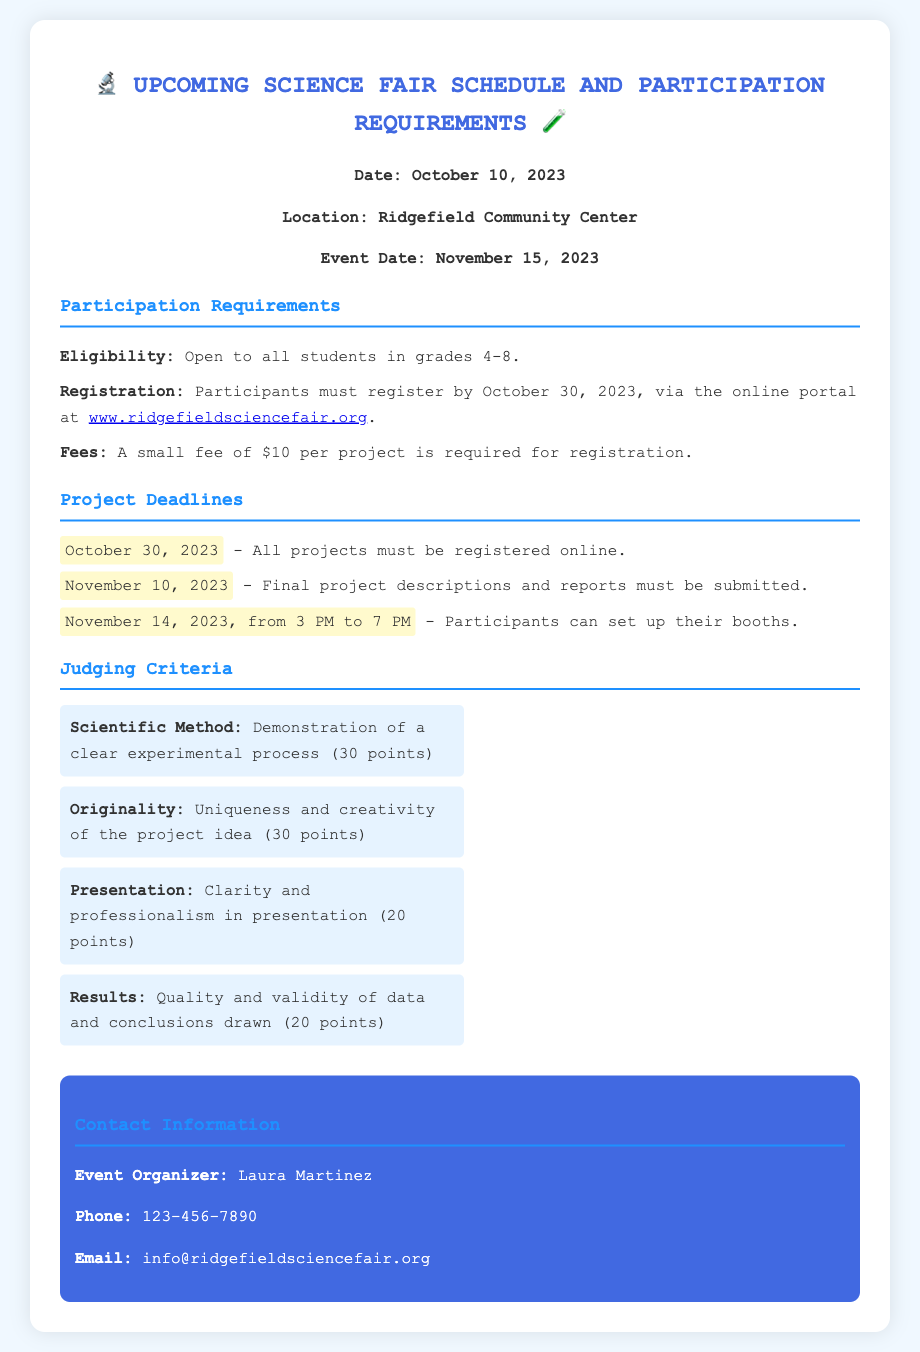What is the registration deadline? The registration deadline is specifically stated in the document as October 30, 2023.
Answer: October 30, 2023 Where is the event taking place? The location of the event is mentioned in the document as Ridgefield Community Center.
Answer: Ridgefield Community Center What is the fee for registration? The document clearly indicates that a small fee is required for registration, stating the amount as $10 per project.
Answer: $10 How many points are awarded for originality? The document specifies that originality is awarded 30 points as part of the judging criteria.
Answer: 30 points What is the setup time for the booths? The document mentions the specific time for booth setup as November 14, 2023, from 3 PM to 7 PM.
Answer: November 14, 2023, from 3 PM to 7 PM Who is the event organizer? The document lists Laura Martinez as the event organizer.
Answer: Laura Martinez How many points are given for the scientific method? According to the judging criteria in the document, the scientific method is allocated 30 points.
Answer: 30 points What must be submitted by November 10, 2023? The document indicates that final project descriptions and reports must be submitted by this date.
Answer: Final project descriptions and reports What is the focus of the judging presentation? The document outlines that clarity and professionalism in presentation is a judging criterion.
Answer: Clarity and professionalism in presentation 